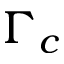<formula> <loc_0><loc_0><loc_500><loc_500>\Gamma _ { c }</formula> 